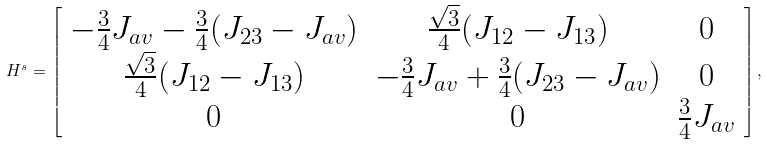<formula> <loc_0><loc_0><loc_500><loc_500>H ^ { s } = \left [ \begin{array} { c c c } - \frac { 3 } { 4 } J _ { a v } - \frac { 3 } { 4 } ( J _ { 2 3 } - J _ { a v } ) & \frac { \sqrt { 3 } } { 4 } ( J _ { 1 2 } - J _ { 1 3 } ) & 0 \\ \frac { \sqrt { 3 } } { 4 } ( J _ { 1 2 } - J _ { 1 3 } ) & - \frac { 3 } { 4 } J _ { a v } + \frac { 3 } { 4 } ( J _ { 2 3 } - J _ { a v } ) & 0 \\ 0 & 0 & \frac { 3 } { 4 } J _ { a v } \\ \end{array} \right ] ,</formula> 